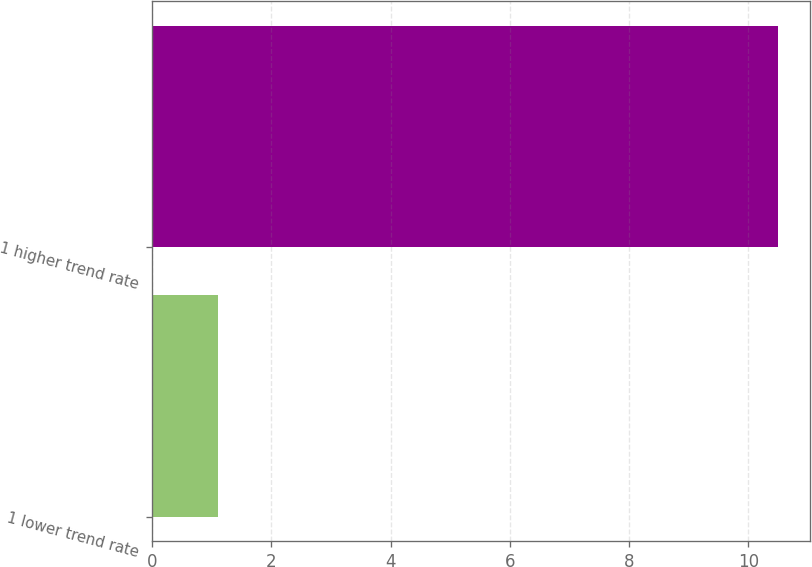<chart> <loc_0><loc_0><loc_500><loc_500><bar_chart><fcel>1 lower trend rate<fcel>1 higher trend rate<nl><fcel>1.1<fcel>10.5<nl></chart> 